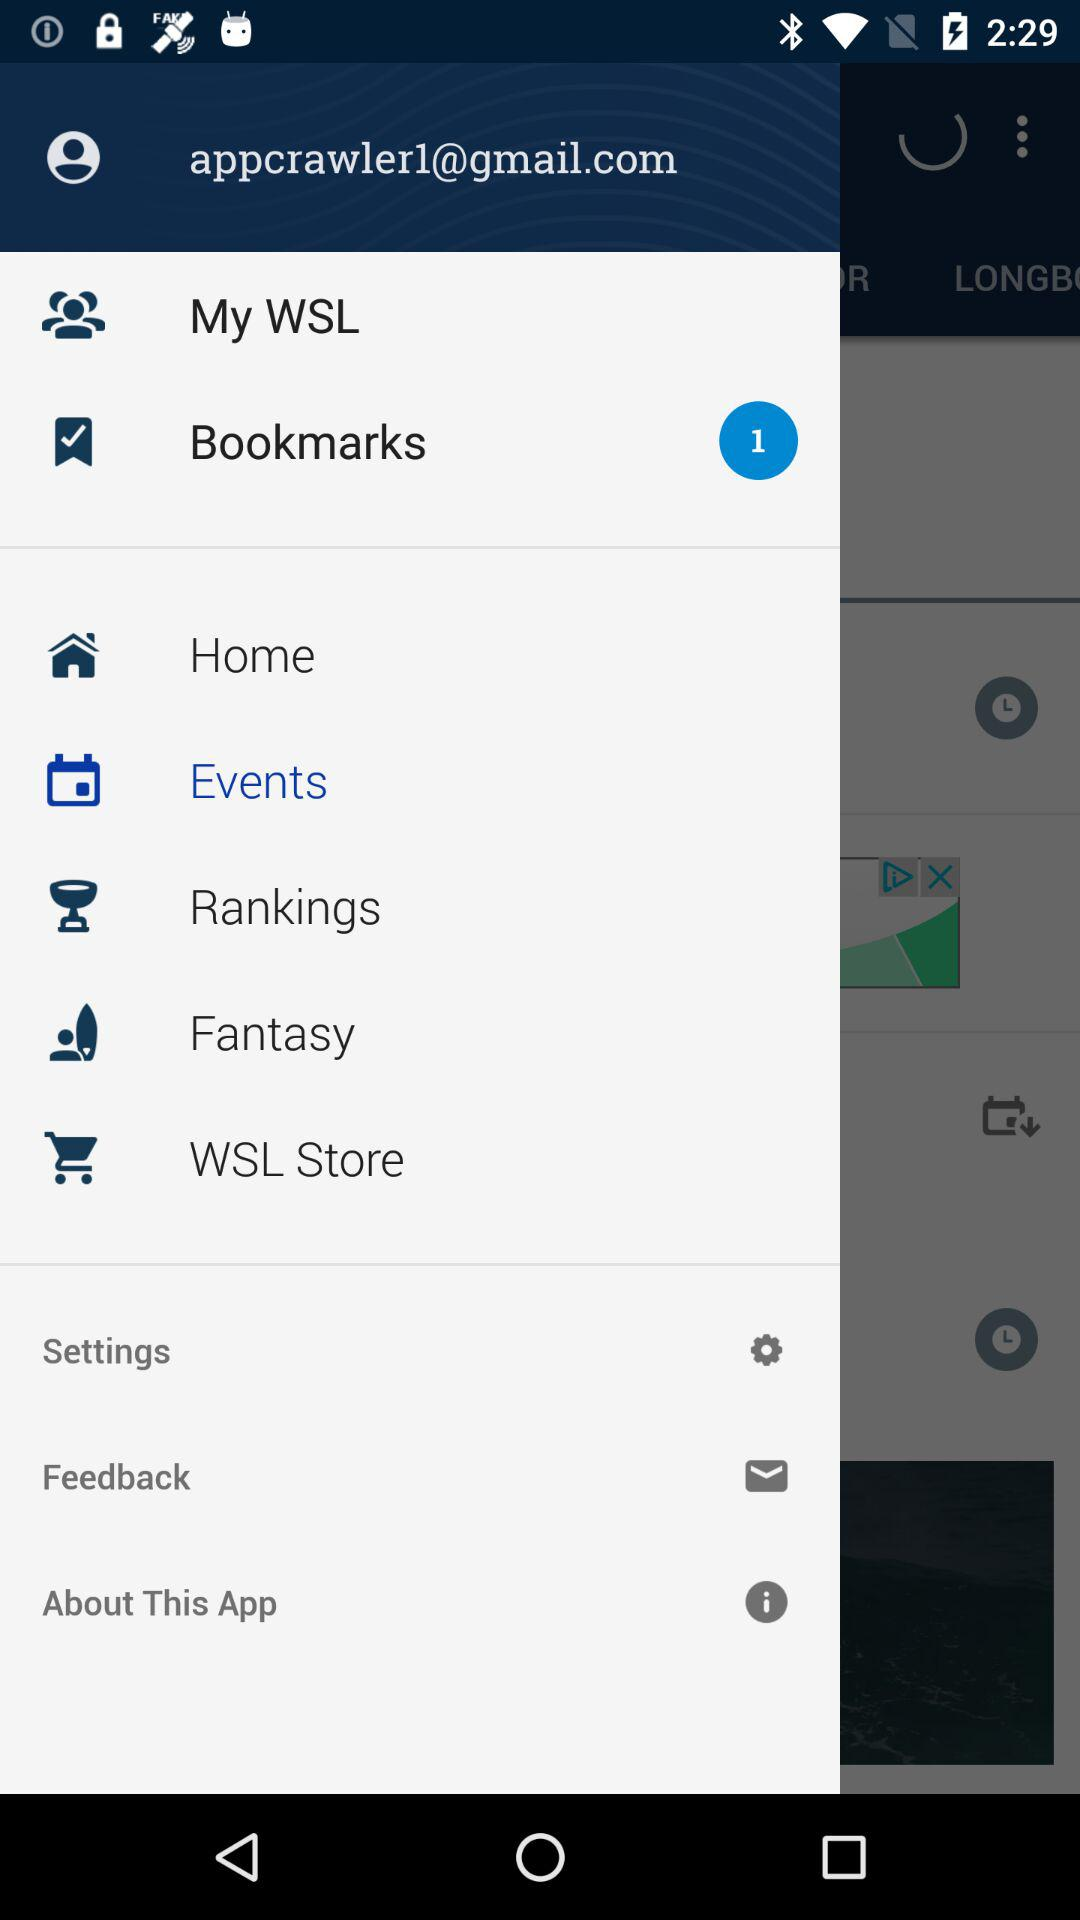Which option is selected? The selected option is "Events". 